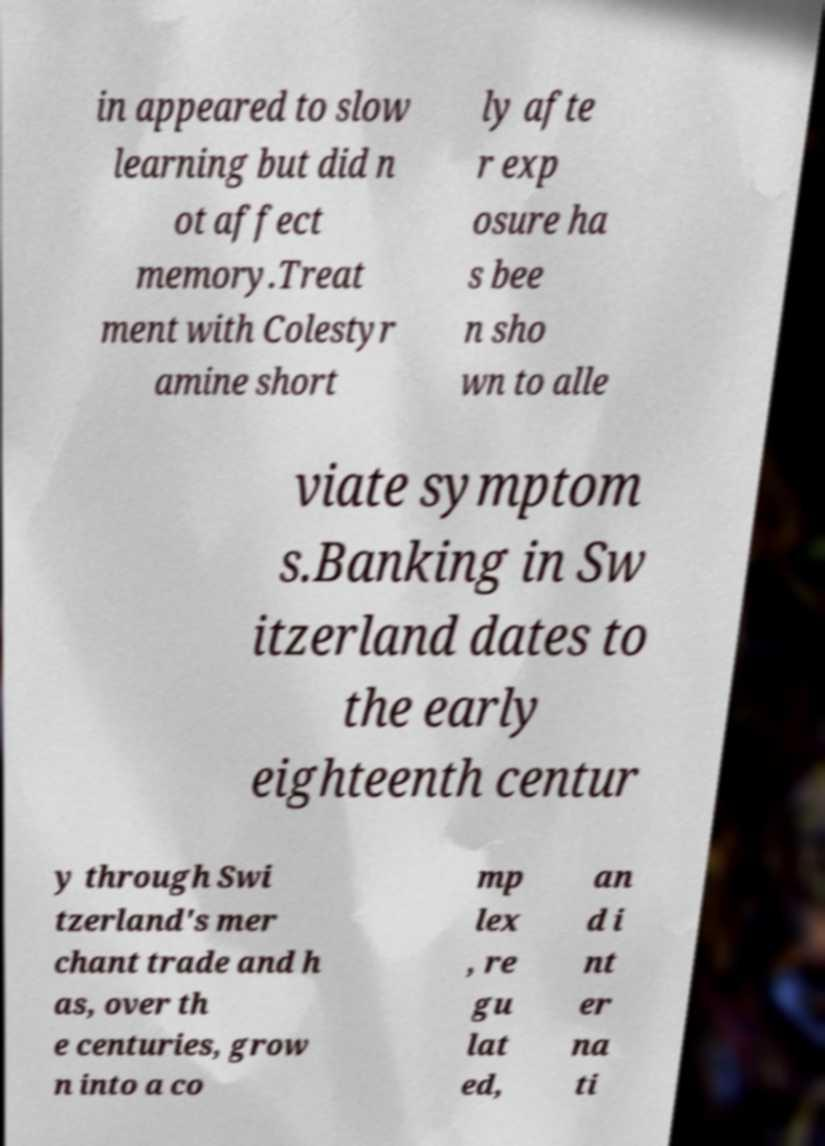For documentation purposes, I need the text within this image transcribed. Could you provide that? in appeared to slow learning but did n ot affect memory.Treat ment with Colestyr amine short ly afte r exp osure ha s bee n sho wn to alle viate symptom s.Banking in Sw itzerland dates to the early eighteenth centur y through Swi tzerland's mer chant trade and h as, over th e centuries, grow n into a co mp lex , re gu lat ed, an d i nt er na ti 